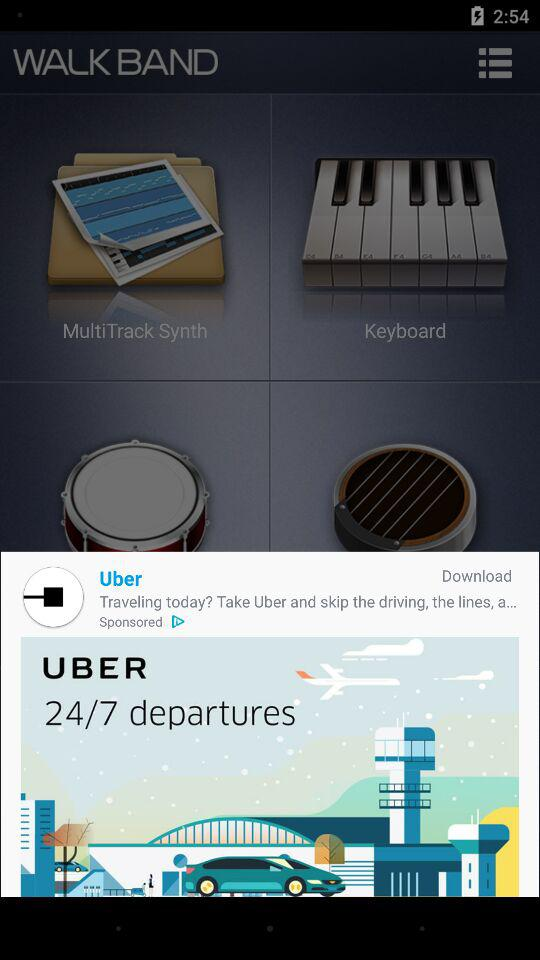What is the duration of "UBER" departures? The duration of departure is 24/7. 